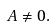Convert formula to latex. <formula><loc_0><loc_0><loc_500><loc_500>A \neq 0 .</formula> 